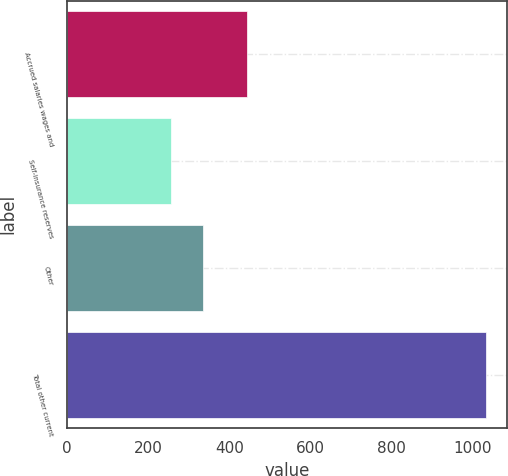Convert chart to OTSL. <chart><loc_0><loc_0><loc_500><loc_500><bar_chart><fcel>Accrued salaries wages and<fcel>Self-insurance reserves<fcel>Other<fcel>Total other current<nl><fcel>444<fcel>256<fcel>334<fcel>1034<nl></chart> 